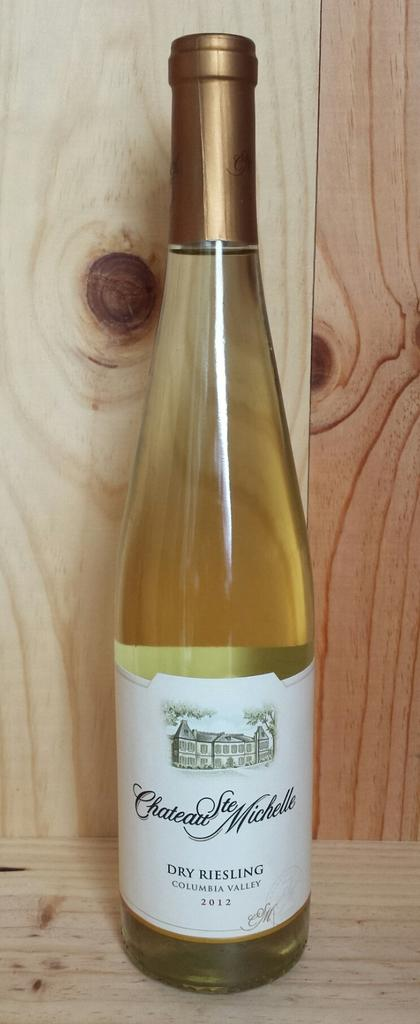<image>
Relay a brief, clear account of the picture shown. A bottle of COLUMBIAN VALLEY is sitting in front of bare wood. 